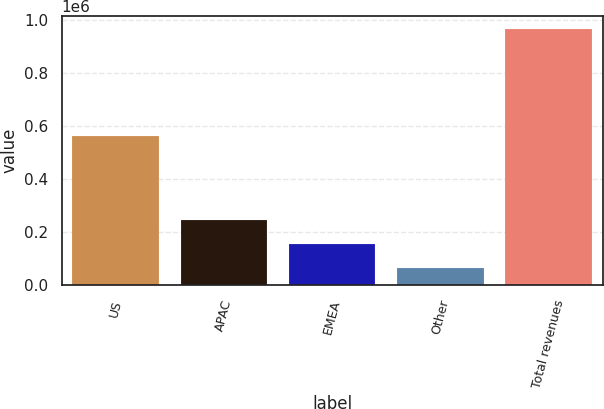Convert chart to OTSL. <chart><loc_0><loc_0><loc_500><loc_500><bar_chart><fcel>US<fcel>APAC<fcel>EMEA<fcel>Other<fcel>Total revenues<nl><fcel>562785<fcel>246619<fcel>156694<fcel>65496<fcel>964748<nl></chart> 